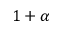Convert formula to latex. <formula><loc_0><loc_0><loc_500><loc_500>1 + \alpha</formula> 